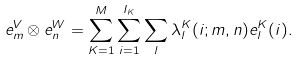Convert formula to latex. <formula><loc_0><loc_0><loc_500><loc_500>e _ { m } ^ { V } \otimes e _ { n } ^ { W } = \sum _ { K = 1 } ^ { M } \sum _ { i = 1 } ^ { I _ { K } } \sum _ { l } \lambda _ { l } ^ { K } ( i ; m , n ) e _ { l } ^ { K } ( i ) .</formula> 